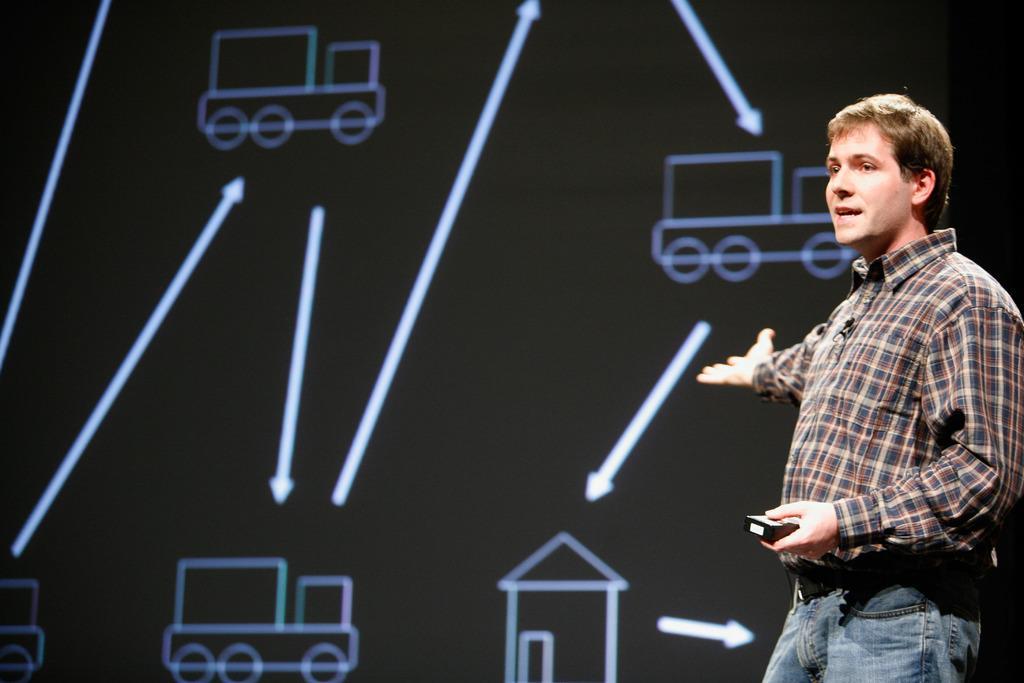Could you give a brief overview of what you see in this image? This image consists of a man talking. He is holding an object in his hand. In the background, it looks like a screen. 